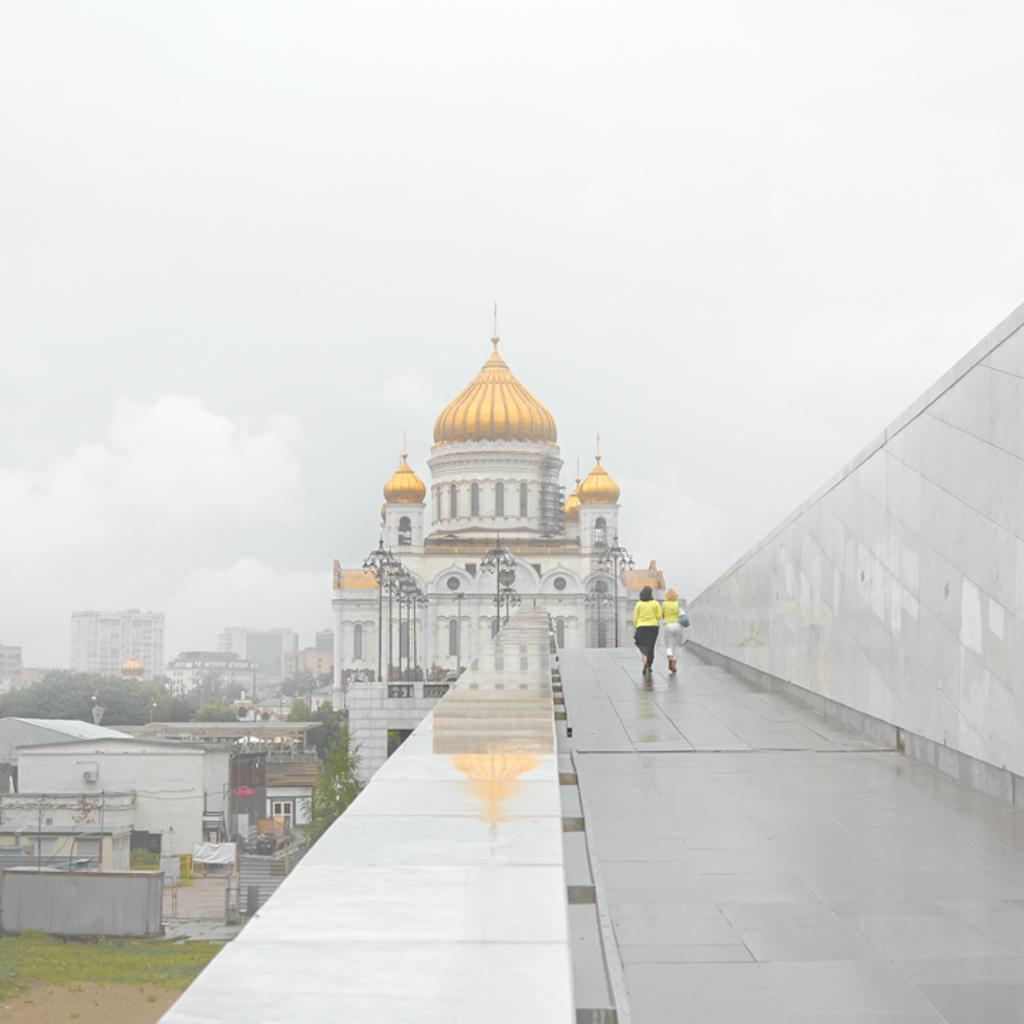What is happening on the right side of the image? There are people walking on the right side of the image. What can be seen in the background of the image? There are buildings and a tower visible in the background of the image. What type of vegetation is present in the image? There are trees in the image. What is visible at the top of the image? The sky is visible at the top of the image. Where is the map located in the image? There is no map present in the image. What type of music is being played by the band in the image? There is no band present in the image. 